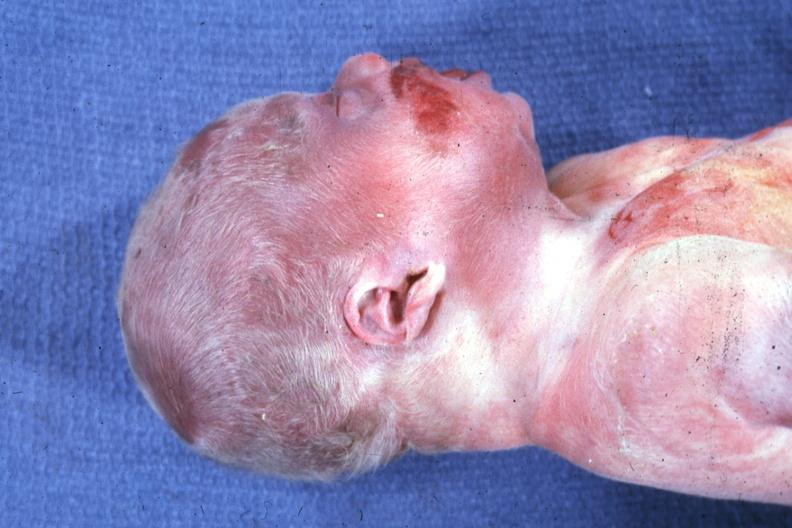what are anterior face whole body showing diastasis recti and kidneys with bilateral pelvic-ureteral strictures?
Answer the question using a single word or phrase. Lateral view of head ear lobe crease web neck other photos in file 